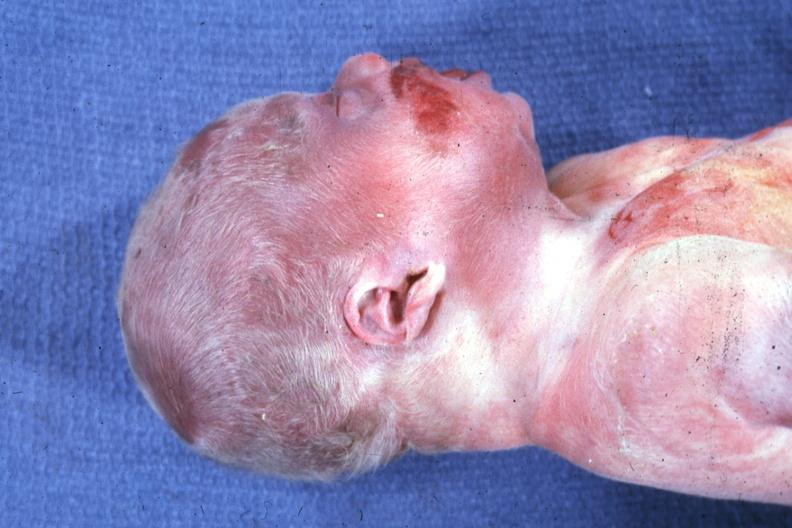what are anterior face whole body showing diastasis recti and kidneys with bilateral pelvic-ureteral strictures?
Answer the question using a single word or phrase. Lateral view of head ear lobe crease web neck other photos in file 